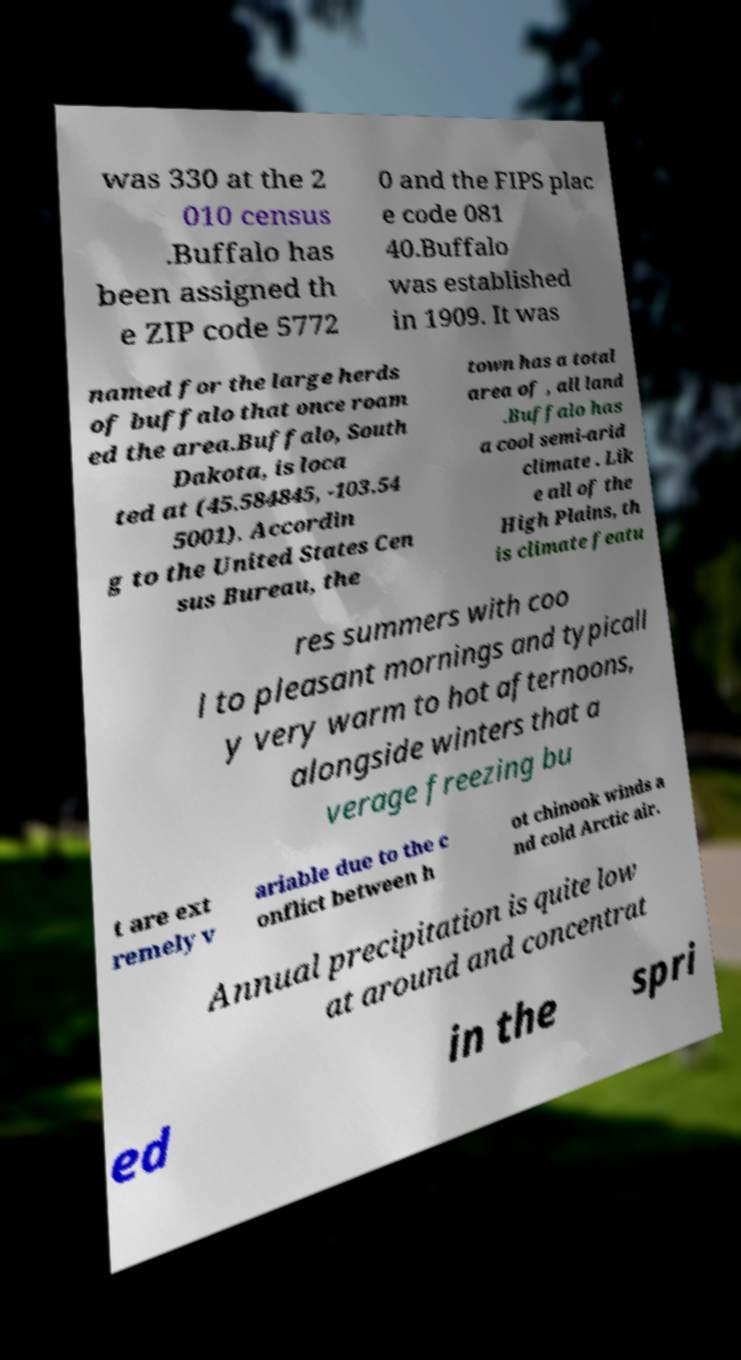Could you extract and type out the text from this image? was 330 at the 2 010 census .Buffalo has been assigned th e ZIP code 5772 0 and the FIPS plac e code 081 40.Buffalo was established in 1909. It was named for the large herds of buffalo that once roam ed the area.Buffalo, South Dakota, is loca ted at (45.584845, -103.54 5001). Accordin g to the United States Cen sus Bureau, the town has a total area of , all land .Buffalo has a cool semi-arid climate . Lik e all of the High Plains, th is climate featu res summers with coo l to pleasant mornings and typicall y very warm to hot afternoons, alongside winters that a verage freezing bu t are ext remely v ariable due to the c onflict between h ot chinook winds a nd cold Arctic air. Annual precipitation is quite low at around and concentrat ed in the spri 